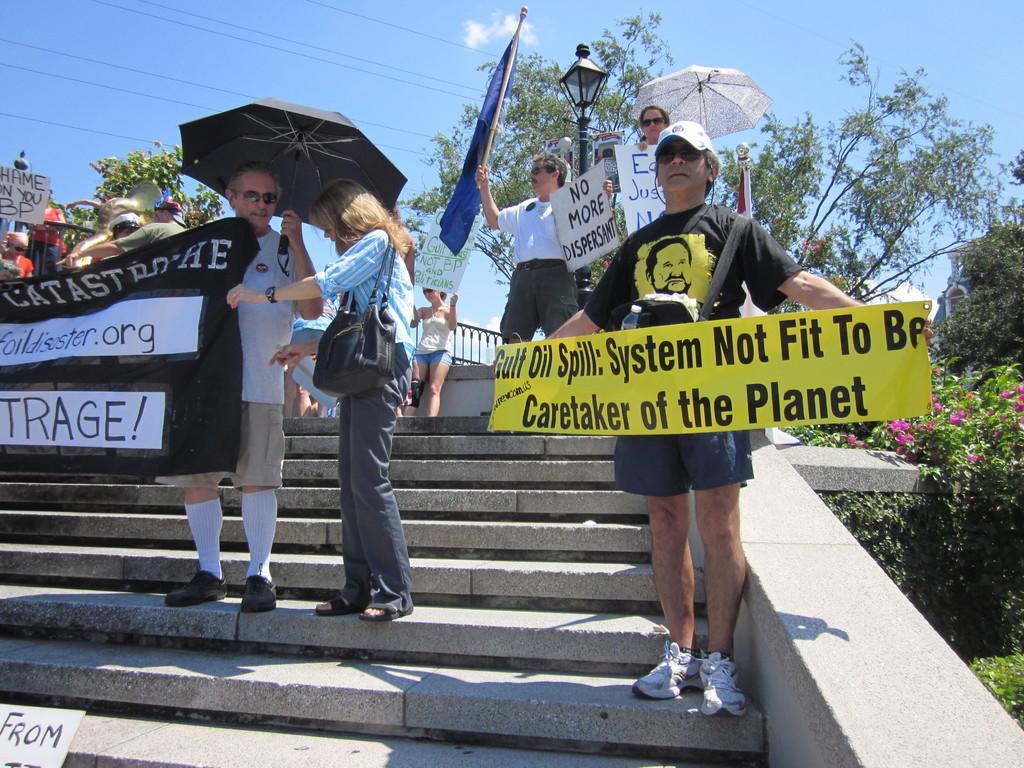How would you summarize this image in a sentence or two? In this picture, we can see a few people holding some objects like posters with some text, and we can see stairs, ground with grass, plants, flowers, poles, wires, lights, and the sky with clouds. 